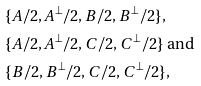Convert formula to latex. <formula><loc_0><loc_0><loc_500><loc_500>& \{ A / 2 , A ^ { \perp } / 2 , B / 2 , B ^ { \perp } / 2 \} , \\ & \{ A / 2 , A ^ { \perp } / 2 , C / 2 , C ^ { \perp } / 2 \} \ \text {and} \\ & \{ B / 2 , B ^ { \perp } / 2 , C / 2 , C ^ { \perp } / 2 \} ,</formula> 